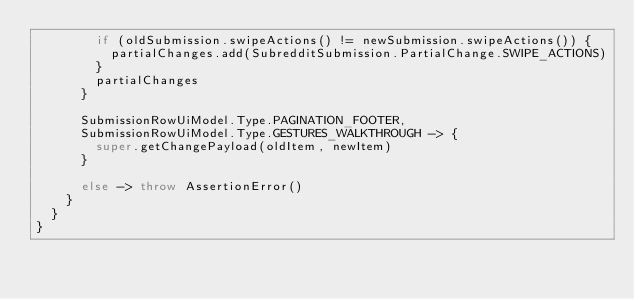<code> <loc_0><loc_0><loc_500><loc_500><_Kotlin_>        if (oldSubmission.swipeActions() != newSubmission.swipeActions()) {
          partialChanges.add(SubredditSubmission.PartialChange.SWIPE_ACTIONS)
        }
        partialChanges
      }

      SubmissionRowUiModel.Type.PAGINATION_FOOTER,
      SubmissionRowUiModel.Type.GESTURES_WALKTHROUGH -> {
        super.getChangePayload(oldItem, newItem)
      }

      else -> throw AssertionError()
    }
  }
}
</code> 